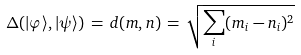<formula> <loc_0><loc_0><loc_500><loc_500>\Delta ( | \varphi \rangle , | \psi \rangle ) \, = \, d ( { m } , { n } ) \, = \, \sqrt { \sum _ { i } ( m _ { i } - n _ { i } ) ^ { 2 } }</formula> 